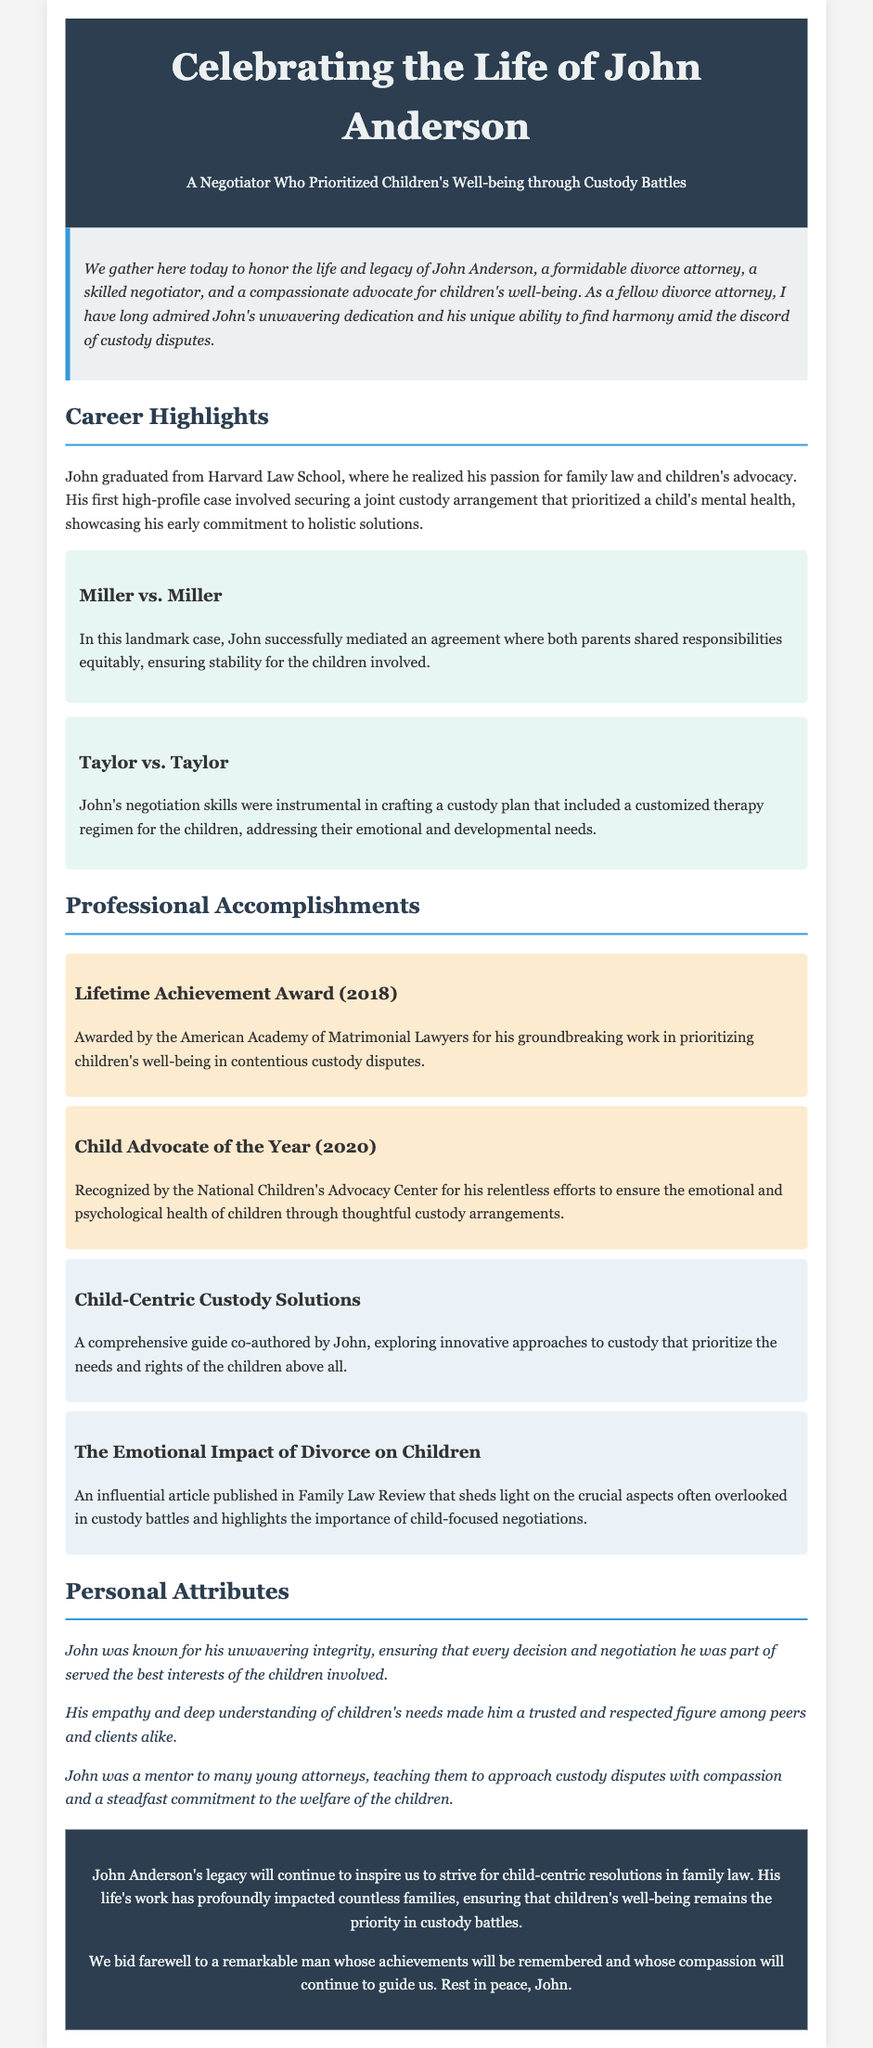What was John's profession? John was a divorce attorney, which is stated in the introduction.
Answer: divorce attorney Which prestigious law school did John graduate from? The document mentions that John graduated from Harvard Law School.
Answer: Harvard Law School What year did John receive the Lifetime Achievement Award? The eulogy states John received the award in 2018.
Answer: 2018 What was a key outcome of the Miller vs. Miller case? The document highlights that John mediated an agreement for equitable shared responsibilities between parents.
Answer: equitable shared responsibilities Which organization recognized John as Child Advocate of the Year? The National Children's Advocacy Center is specified as the awarding body for this recognition.
Answer: National Children's Advocacy Center What was the focus of John's published guide "Child-Centric Custody Solutions"? The guide explored innovative approaches to custody emphasizing the needs and rights of children.
Answer: needs and rights of children How did John approach custody disputes according to his personal attributes? The document notes that John approached disputes with compassion and a commitment to children's welfare.
Answer: compassion and commitment to children's welfare What does the eulogy suggest about John's legacy? It suggests that John's legacy will inspire striving for child-centric resolutions in family law.
Answer: inspire striving for child-centric resolutions In which publication did John discuss "The Emotional Impact of Divorce on Children"? The publication is mentioned as Family Law Review.
Answer: Family Law Review 